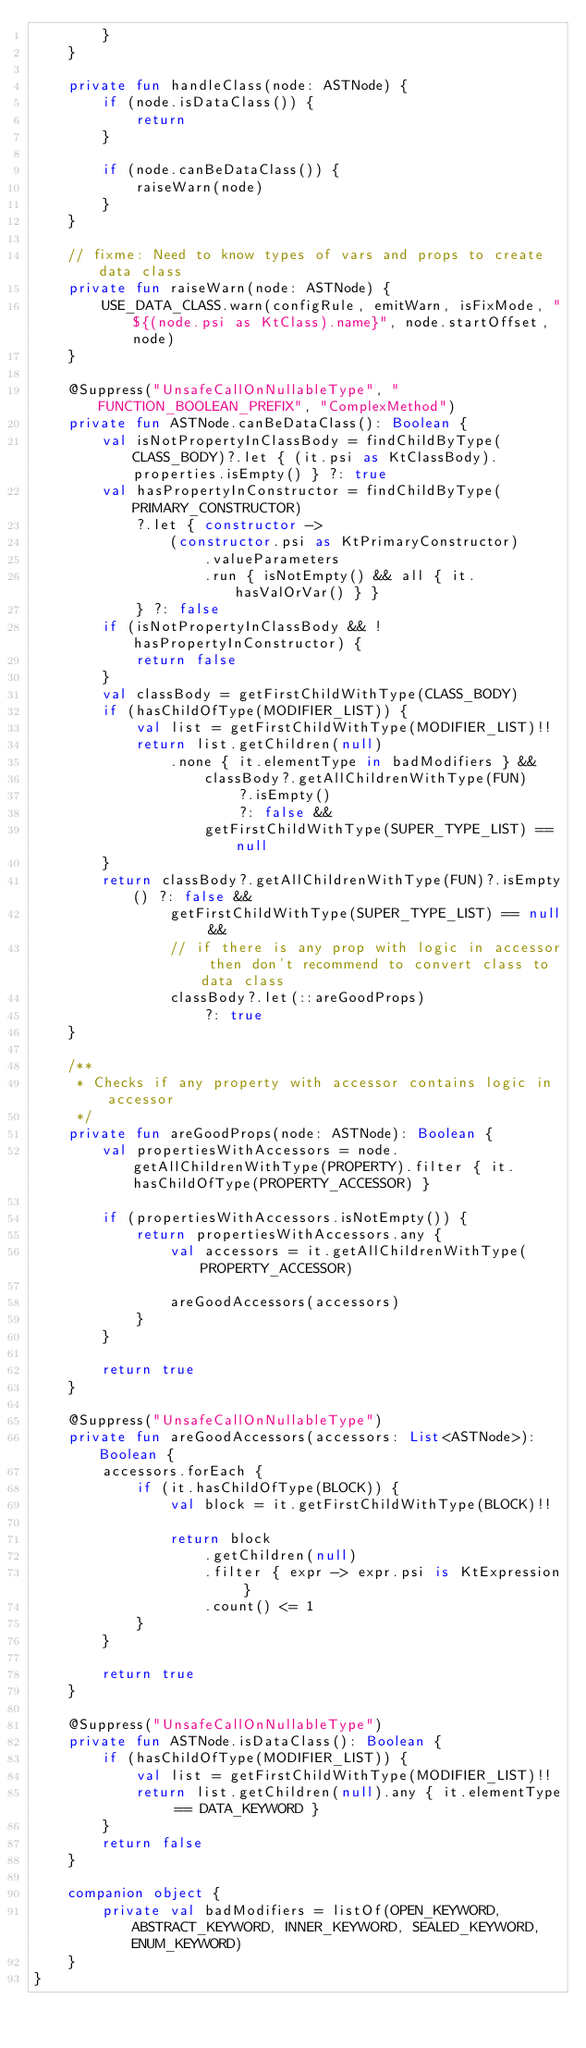Convert code to text. <code><loc_0><loc_0><loc_500><loc_500><_Kotlin_>        }
    }

    private fun handleClass(node: ASTNode) {
        if (node.isDataClass()) {
            return
        }

        if (node.canBeDataClass()) {
            raiseWarn(node)
        }
    }

    // fixme: Need to know types of vars and props to create data class
    private fun raiseWarn(node: ASTNode) {
        USE_DATA_CLASS.warn(configRule, emitWarn, isFixMode, "${(node.psi as KtClass).name}", node.startOffset, node)
    }

    @Suppress("UnsafeCallOnNullableType", "FUNCTION_BOOLEAN_PREFIX", "ComplexMethod")
    private fun ASTNode.canBeDataClass(): Boolean {
        val isNotPropertyInClassBody = findChildByType(CLASS_BODY)?.let { (it.psi as KtClassBody).properties.isEmpty() } ?: true
        val hasPropertyInConstructor = findChildByType(PRIMARY_CONSTRUCTOR)
            ?.let { constructor ->
                (constructor.psi as KtPrimaryConstructor)
                    .valueParameters
                    .run { isNotEmpty() && all { it.hasValOrVar() } }
            } ?: false
        if (isNotPropertyInClassBody && !hasPropertyInConstructor) {
            return false
        }
        val classBody = getFirstChildWithType(CLASS_BODY)
        if (hasChildOfType(MODIFIER_LIST)) {
            val list = getFirstChildWithType(MODIFIER_LIST)!!
            return list.getChildren(null)
                .none { it.elementType in badModifiers } &&
                    classBody?.getAllChildrenWithType(FUN)
                        ?.isEmpty()
                        ?: false &&
                    getFirstChildWithType(SUPER_TYPE_LIST) == null
        }
        return classBody?.getAllChildrenWithType(FUN)?.isEmpty() ?: false &&
                getFirstChildWithType(SUPER_TYPE_LIST) == null &&
                // if there is any prop with logic in accessor then don't recommend to convert class to data class
                classBody?.let(::areGoodProps)
                    ?: true
    }

    /**
     * Checks if any property with accessor contains logic in accessor
     */
    private fun areGoodProps(node: ASTNode): Boolean {
        val propertiesWithAccessors = node.getAllChildrenWithType(PROPERTY).filter { it.hasChildOfType(PROPERTY_ACCESSOR) }

        if (propertiesWithAccessors.isNotEmpty()) {
            return propertiesWithAccessors.any {
                val accessors = it.getAllChildrenWithType(PROPERTY_ACCESSOR)

                areGoodAccessors(accessors)
            }
        }

        return true
    }

    @Suppress("UnsafeCallOnNullableType")
    private fun areGoodAccessors(accessors: List<ASTNode>): Boolean {
        accessors.forEach {
            if (it.hasChildOfType(BLOCK)) {
                val block = it.getFirstChildWithType(BLOCK)!!

                return block
                    .getChildren(null)
                    .filter { expr -> expr.psi is KtExpression }
                    .count() <= 1
            }
        }

        return true
    }

    @Suppress("UnsafeCallOnNullableType")
    private fun ASTNode.isDataClass(): Boolean {
        if (hasChildOfType(MODIFIER_LIST)) {
            val list = getFirstChildWithType(MODIFIER_LIST)!!
            return list.getChildren(null).any { it.elementType == DATA_KEYWORD }
        }
        return false
    }

    companion object {
        private val badModifiers = listOf(OPEN_KEYWORD, ABSTRACT_KEYWORD, INNER_KEYWORD, SEALED_KEYWORD, ENUM_KEYWORD)
    }
}
</code> 